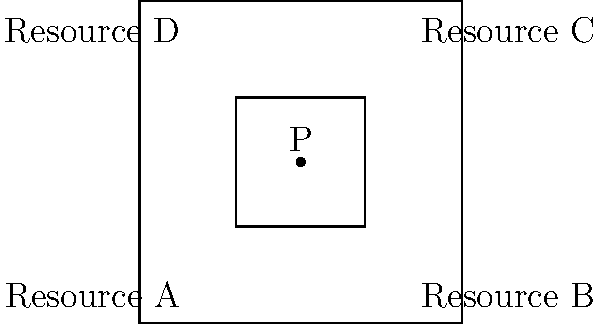In a developing nation, four major resources (A, B, C, D) are distributed across different regions. Using projective geometry, a central point P is identified to represent the balanced distribution of these resources. If the cross-ratio $(ABCD) = k$, what is the value of $k$ that ensures optimal resource allocation? To solve this problem, we'll use the principles of projective geometry and cross-ratio:

1) In projective geometry, the cross-ratio is invariant under projective transformations. This property makes it useful for representing resource distribution.

2) The cross-ratio of four collinear points A, B, C, D is defined as:

   $$(ABCD) = \frac{AC \cdot BD}{AD \cdot BC}$$

3) In our case, the points are not collinear, but we can use the central point P to project them onto a line.

4) For optimal resource allocation, we want the cross-ratio to represent a balanced distribution. In projective geometry, the most balanced configuration is often represented by the harmonic cross-ratio.

5) The harmonic cross-ratio occurs when $(ABCD) = -1$. This configuration ensures that P is the harmonic conjugate of each pair of opposite points.

6) When $(ABCD) = -1$, it means that P divides AC and BD in the same ratio, which geometrically represents a balanced distribution of resources.

Therefore, for optimal resource allocation, we should aim for:

   $$k = (ABCD) = -1$$

This value ensures that the central point P represents a balanced distribution of the four resources across the nation.
Answer: $k = -1$ 